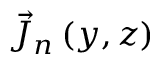Convert formula to latex. <formula><loc_0><loc_0><loc_500><loc_500>\vec { J } _ { n } \left ( y , z \right )</formula> 